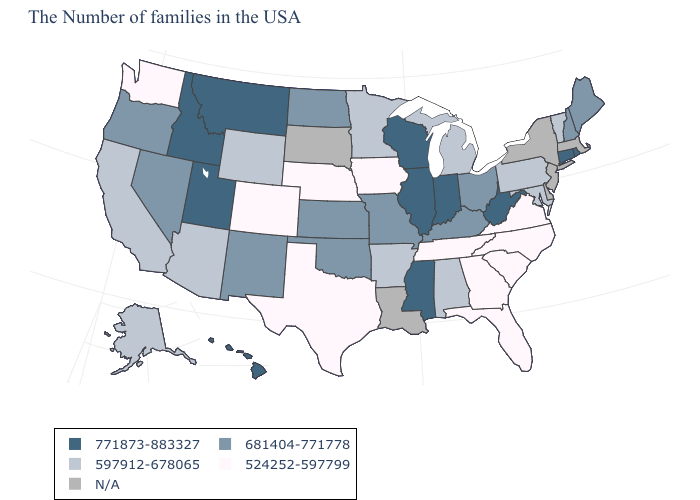Name the states that have a value in the range N/A?
Answer briefly. Massachusetts, New York, New Jersey, Delaware, Louisiana, South Dakota. What is the value of South Carolina?
Quick response, please. 524252-597799. Among the states that border Arkansas , does Tennessee have the lowest value?
Quick response, please. Yes. Name the states that have a value in the range 681404-771778?
Answer briefly. Maine, New Hampshire, Ohio, Kentucky, Missouri, Kansas, Oklahoma, North Dakota, New Mexico, Nevada, Oregon. Does Connecticut have the highest value in the USA?
Keep it brief. Yes. Which states have the lowest value in the Northeast?
Be succinct. Vermont, Pennsylvania. What is the lowest value in the USA?
Be succinct. 524252-597799. How many symbols are there in the legend?
Short answer required. 5. Which states have the lowest value in the USA?
Short answer required. Virginia, North Carolina, South Carolina, Florida, Georgia, Tennessee, Iowa, Nebraska, Texas, Colorado, Washington. What is the highest value in states that border North Carolina?
Give a very brief answer. 524252-597799. Name the states that have a value in the range 597912-678065?
Be succinct. Vermont, Maryland, Pennsylvania, Michigan, Alabama, Arkansas, Minnesota, Wyoming, Arizona, California, Alaska. What is the lowest value in states that border Iowa?
Answer briefly. 524252-597799. Name the states that have a value in the range N/A?
Write a very short answer. Massachusetts, New York, New Jersey, Delaware, Louisiana, South Dakota. Name the states that have a value in the range 524252-597799?
Concise answer only. Virginia, North Carolina, South Carolina, Florida, Georgia, Tennessee, Iowa, Nebraska, Texas, Colorado, Washington. 